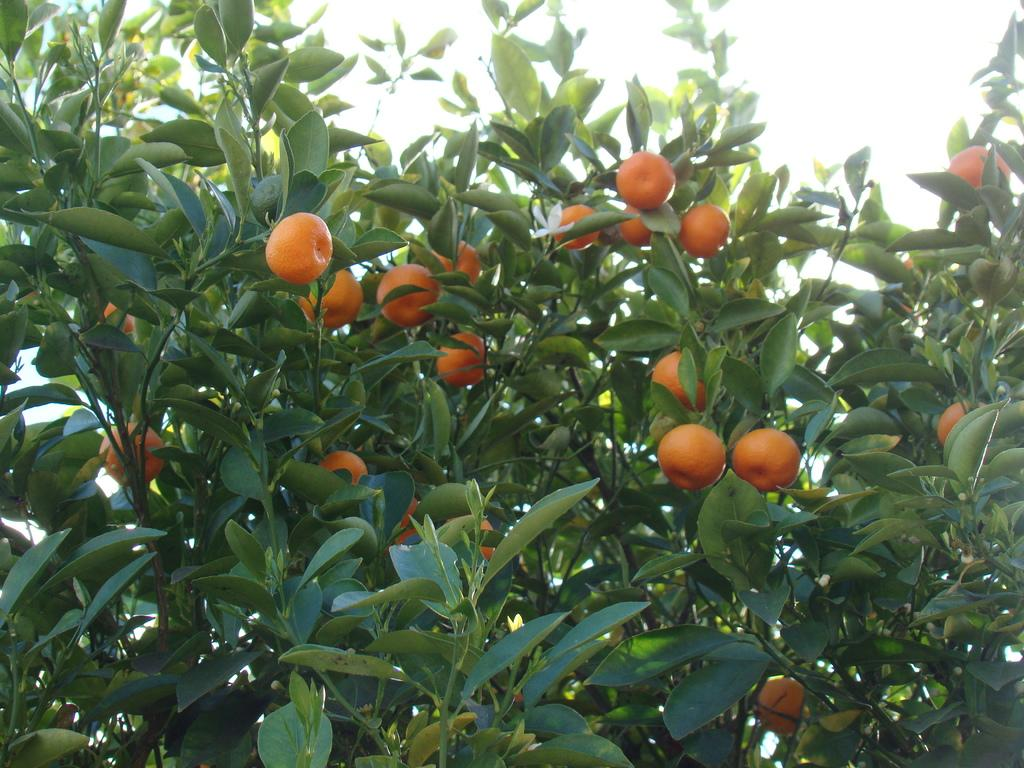What type of vegetation is present in the image? There are trees with fruits in the image. What can be seen in the background of the image? The sky is visible in the background of the image. Where is the basketball court located in the image? There is no basketball court present in the image. What type of container is used to hold arrows in the image? There are no arrows or quivers present in the image. 